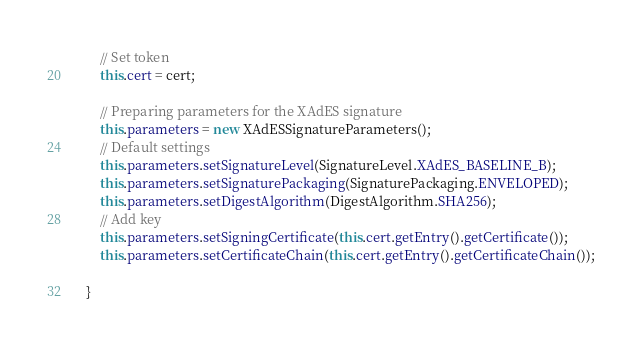<code> <loc_0><loc_0><loc_500><loc_500><_Java_>        // Set token
        this.cert = cert;

        // Preparing parameters for the XAdES signature
        this.parameters = new XAdESSignatureParameters();
        // Default settings
        this.parameters.setSignatureLevel(SignatureLevel.XAdES_BASELINE_B);
        this.parameters.setSignaturePackaging(SignaturePackaging.ENVELOPED);
        this.parameters.setDigestAlgorithm(DigestAlgorithm.SHA256);
        // Add key
        this.parameters.setSigningCertificate(this.cert.getEntry().getCertificate());
        this.parameters.setCertificateChain(this.cert.getEntry().getCertificateChain());

    }
</code> 